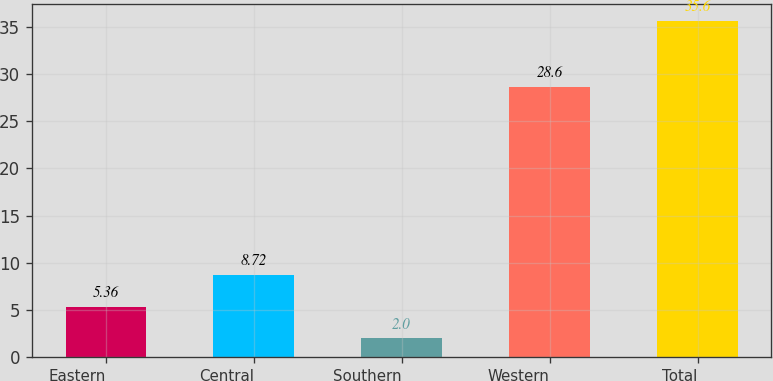Convert chart to OTSL. <chart><loc_0><loc_0><loc_500><loc_500><bar_chart><fcel>Eastern<fcel>Central<fcel>Southern<fcel>Western<fcel>Total<nl><fcel>5.36<fcel>8.72<fcel>2<fcel>28.6<fcel>35.6<nl></chart> 